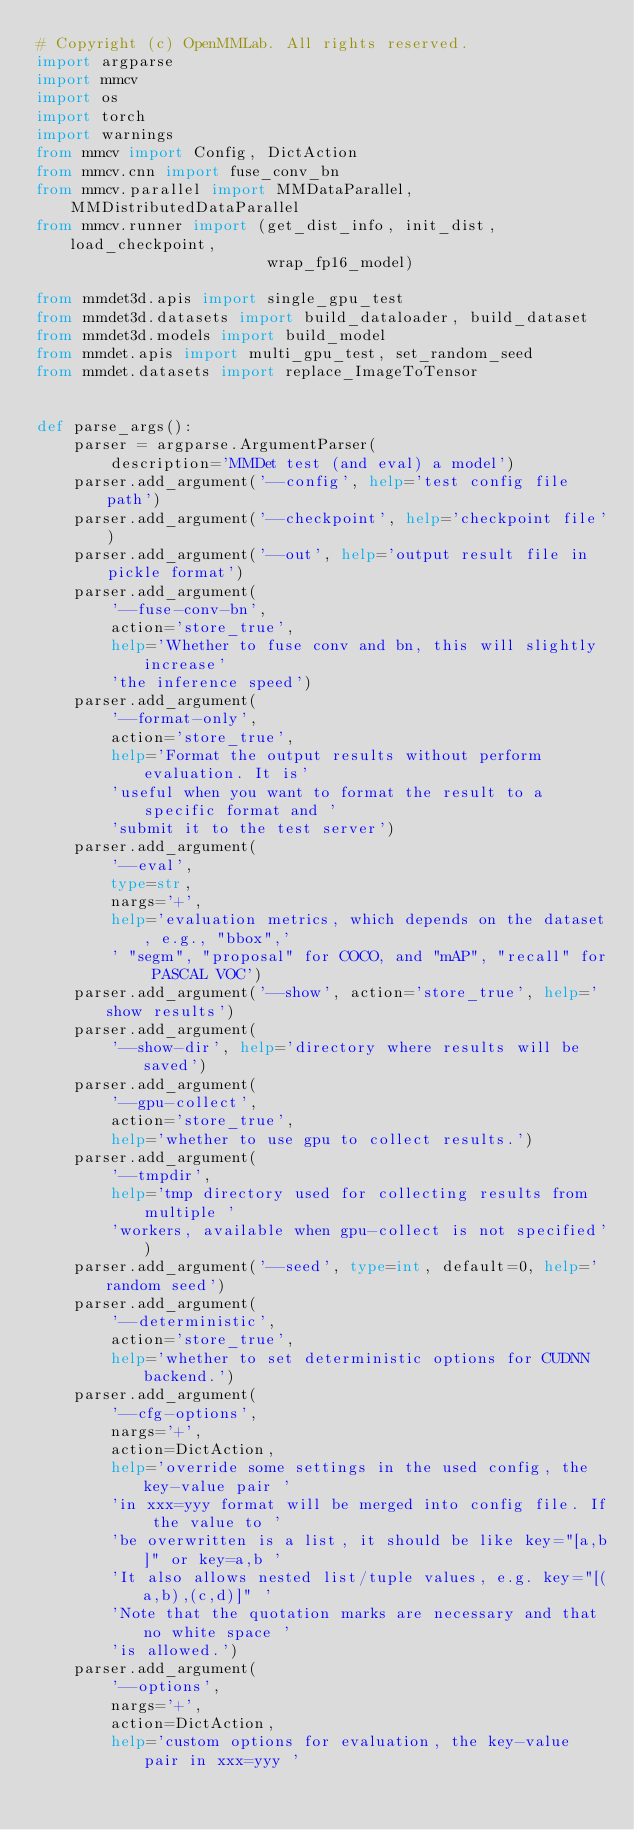Convert code to text. <code><loc_0><loc_0><loc_500><loc_500><_Python_># Copyright (c) OpenMMLab. All rights reserved.
import argparse
import mmcv
import os
import torch
import warnings
from mmcv import Config, DictAction
from mmcv.cnn import fuse_conv_bn
from mmcv.parallel import MMDataParallel, MMDistributedDataParallel
from mmcv.runner import (get_dist_info, init_dist, load_checkpoint,
                         wrap_fp16_model)

from mmdet3d.apis import single_gpu_test
from mmdet3d.datasets import build_dataloader, build_dataset
from mmdet3d.models import build_model
from mmdet.apis import multi_gpu_test, set_random_seed
from mmdet.datasets import replace_ImageToTensor


def parse_args():
    parser = argparse.ArgumentParser(
        description='MMDet test (and eval) a model')
    parser.add_argument('--config', help='test config file path')
    parser.add_argument('--checkpoint', help='checkpoint file')
    parser.add_argument('--out', help='output result file in pickle format')
    parser.add_argument(
        '--fuse-conv-bn',
        action='store_true',
        help='Whether to fuse conv and bn, this will slightly increase'
        'the inference speed')
    parser.add_argument(
        '--format-only',
        action='store_true',
        help='Format the output results without perform evaluation. It is'
        'useful when you want to format the result to a specific format and '
        'submit it to the test server')
    parser.add_argument(
        '--eval',
        type=str,
        nargs='+',
        help='evaluation metrics, which depends on the dataset, e.g., "bbox",'
        ' "segm", "proposal" for COCO, and "mAP", "recall" for PASCAL VOC')
    parser.add_argument('--show', action='store_true', help='show results')
    parser.add_argument(
        '--show-dir', help='directory where results will be saved')
    parser.add_argument(
        '--gpu-collect',
        action='store_true',
        help='whether to use gpu to collect results.')
    parser.add_argument(
        '--tmpdir',
        help='tmp directory used for collecting results from multiple '
        'workers, available when gpu-collect is not specified')
    parser.add_argument('--seed', type=int, default=0, help='random seed')
    parser.add_argument(
        '--deterministic',
        action='store_true',
        help='whether to set deterministic options for CUDNN backend.')
    parser.add_argument(
        '--cfg-options',
        nargs='+',
        action=DictAction,
        help='override some settings in the used config, the key-value pair '
        'in xxx=yyy format will be merged into config file. If the value to '
        'be overwritten is a list, it should be like key="[a,b]" or key=a,b '
        'It also allows nested list/tuple values, e.g. key="[(a,b),(c,d)]" '
        'Note that the quotation marks are necessary and that no white space '
        'is allowed.')
    parser.add_argument(
        '--options',
        nargs='+',
        action=DictAction,
        help='custom options for evaluation, the key-value pair in xxx=yyy '</code> 